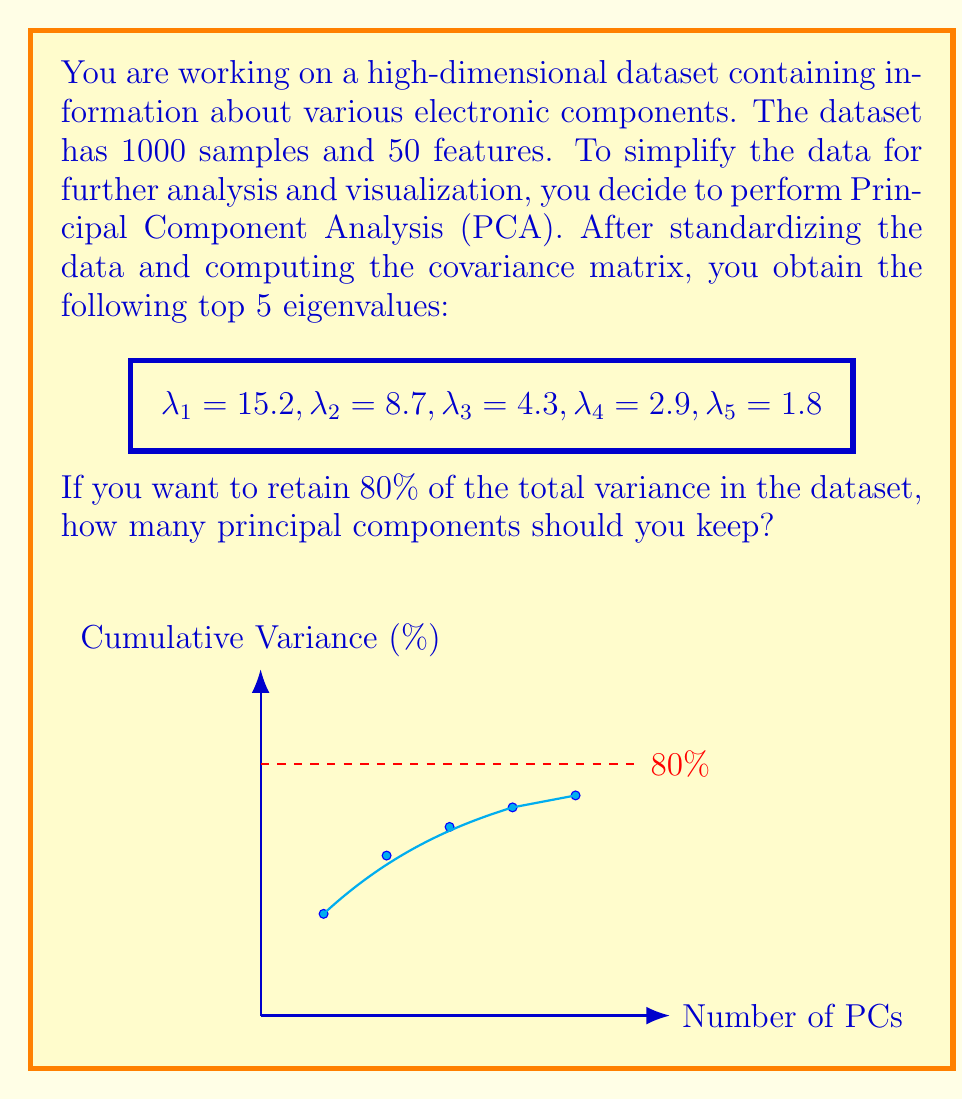Give your solution to this math problem. To determine the number of principal components to retain, we need to calculate the cumulative proportion of variance explained by each component and find where it exceeds 80%. Let's follow these steps:

1) Calculate the total variance:
   $$\text{Total Variance} = \sum_{i=1}^{50} \lambda_i$$
   We don't have all 50 eigenvalues, but we can use the given top 5 for this example.
   $$\text{Total Variance} ≈ 15.2 + 8.7 + 4.3 + 2.9 + 1.8 = 32.9$$

2) Calculate the proportion of variance explained by each component:
   $$\text{Proportion}_i = \frac{\lambda_i}{\text{Total Variance}}$$

   For the first component: $\frac{15.2}{32.9} ≈ 0.4620$ or 46.20%
   For the second component: $\frac{8.7}{32.9} ≈ 0.2645$ or 26.45%
   For the third component: $\frac{4.3}{32.9} ≈ 0.1307$ or 13.07%
   For the fourth component: $\frac{2.9}{32.9} ≈ 0.0881$ or 8.81%

3) Calculate the cumulative proportion of variance:
   1st PC: 46.20%
   1st + 2nd PCs: 46.20% + 26.45% = 72.65%
   1st + 2nd + 3rd PCs: 72.65% + 13.07% = 85.72%

4) We see that after including the third principal component, we exceed the 80% threshold. Therefore, we need to keep 3 principal components to retain at least 80% of the total variance in the dataset.
Answer: 3 principal components 